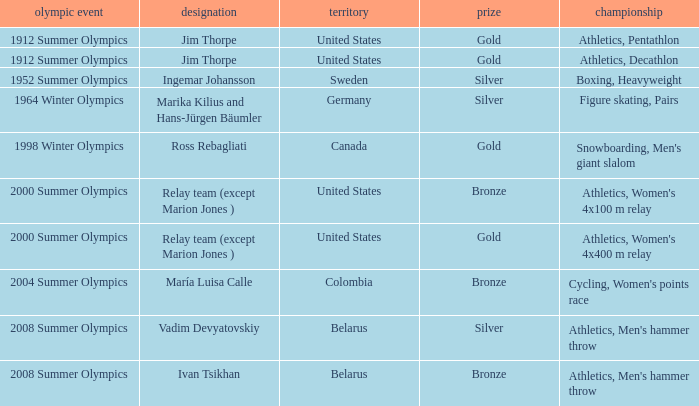What is the event in the 2000 summer olympics with a bronze medal? Athletics, Women's 4x100 m relay. 